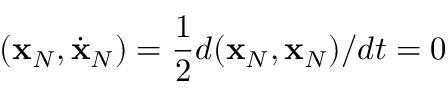Convert formula to latex. <formula><loc_0><loc_0><loc_500><loc_500>( { x } _ { N } , \dot { x } _ { N } ) = \frac { 1 } { 2 } d ( { x } _ { N } , { x } _ { N } ) / d t = 0</formula> 